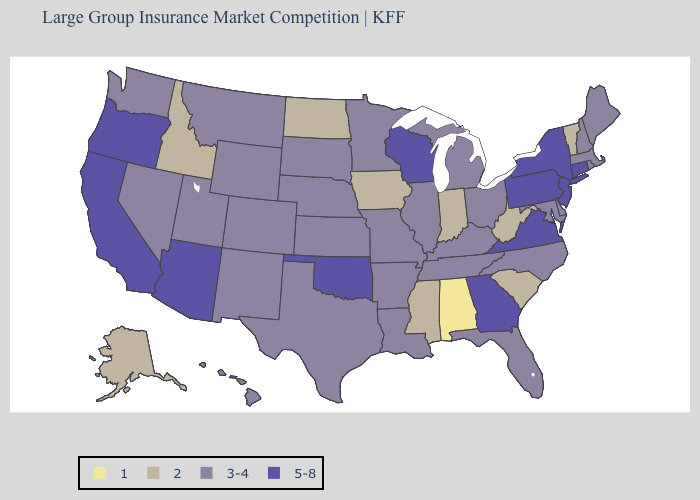What is the lowest value in the South?
Answer briefly. 1. What is the highest value in the Northeast ?
Be succinct. 5-8. What is the highest value in the USA?
Write a very short answer. 5-8. What is the lowest value in the USA?
Write a very short answer. 1. Name the states that have a value in the range 5-8?
Answer briefly. Arizona, California, Connecticut, Georgia, New Jersey, New York, Oklahoma, Oregon, Pennsylvania, Virginia, Wisconsin. Among the states that border Missouri , which have the highest value?
Answer briefly. Oklahoma. Does Kansas have the lowest value in the MidWest?
Keep it brief. No. What is the value of Virginia?
Keep it brief. 5-8. Name the states that have a value in the range 2?
Short answer required. Alaska, Idaho, Indiana, Iowa, Mississippi, North Dakota, South Carolina, Vermont, West Virginia. What is the lowest value in the USA?
Concise answer only. 1. What is the value of Wyoming?
Quick response, please. 3-4. What is the value of Kansas?
Keep it brief. 3-4. What is the lowest value in the USA?
Be succinct. 1. Is the legend a continuous bar?
Write a very short answer. No. Among the states that border Tennessee , does Alabama have the lowest value?
Quick response, please. Yes. 